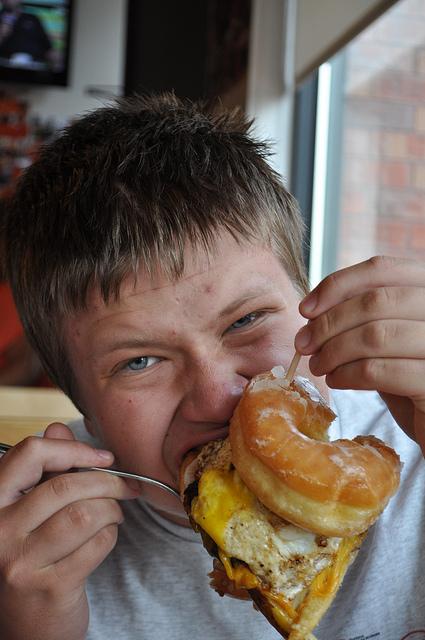What is under the doughnut?
Be succinct. Egg. Is he hungry?
Answer briefly. Yes. Is the meal pictured a low cholesterol meal?
Concise answer only. No. Does the person with the sandwich like pickles?
Keep it brief. No. 